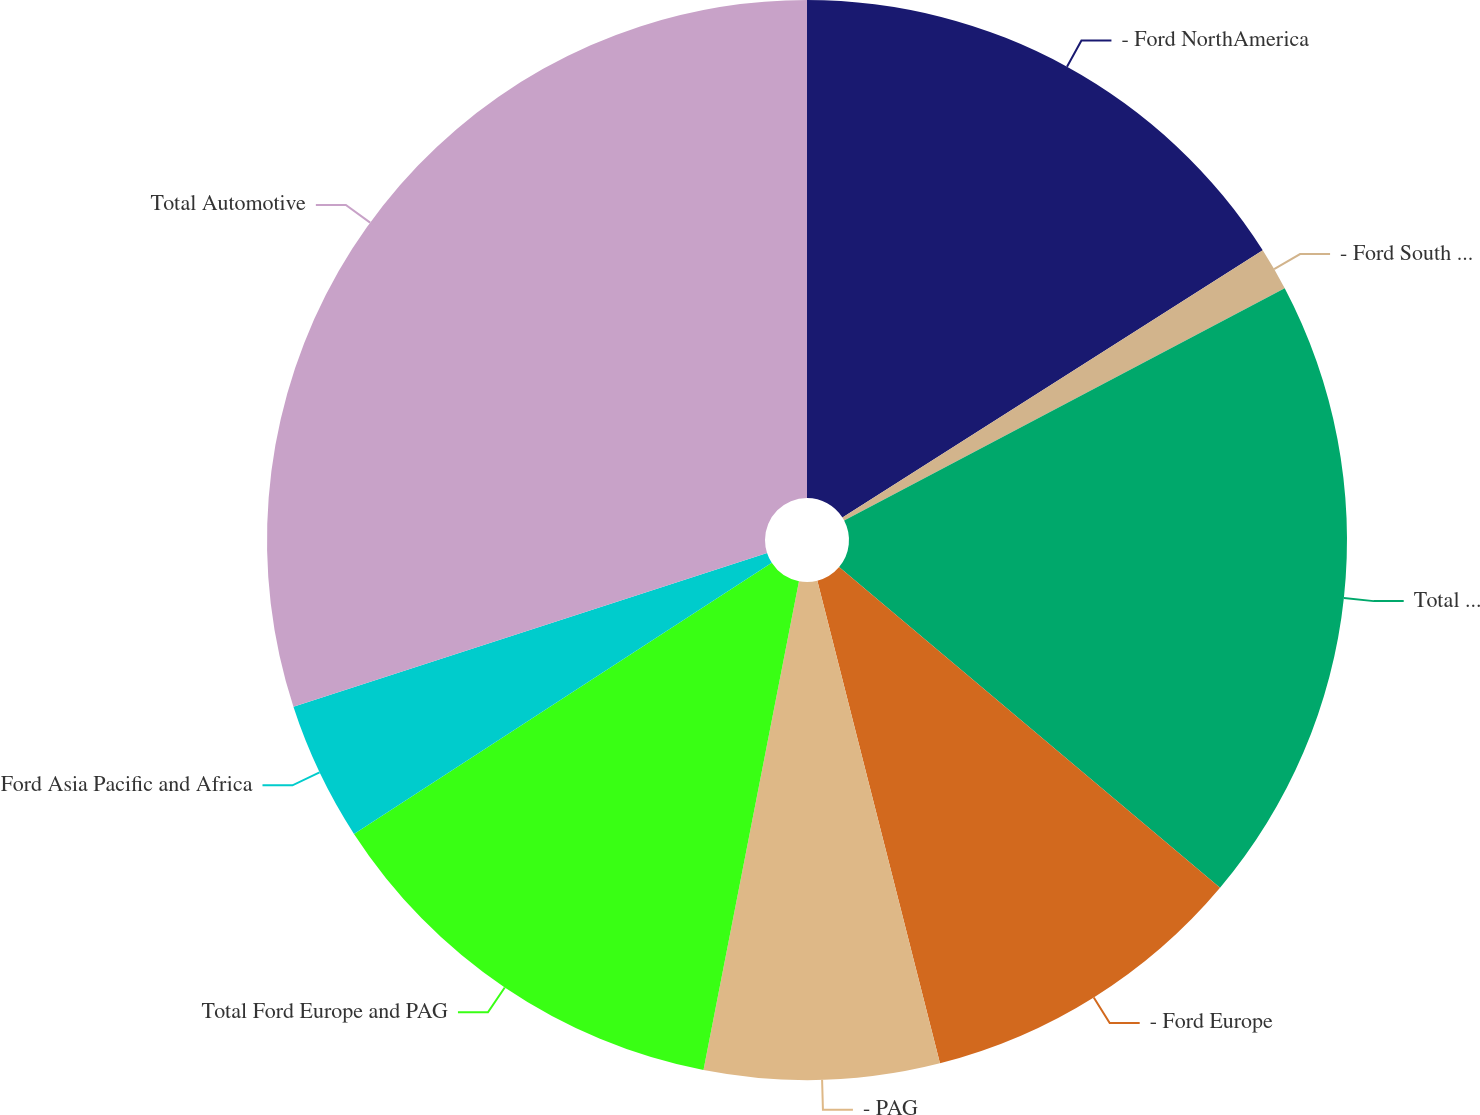Convert chart. <chart><loc_0><loc_0><loc_500><loc_500><pie_chart><fcel>- Ford NorthAmerica<fcel>- Ford South America<fcel>Total Americas<fcel>- Ford Europe<fcel>- PAG<fcel>Total Ford Europe and PAG<fcel>Ford Asia Pacific and Africa<fcel>Total Automotive<nl><fcel>15.99%<fcel>1.29%<fcel>18.86%<fcel>9.9%<fcel>7.03%<fcel>12.77%<fcel>4.16%<fcel>30.0%<nl></chart> 